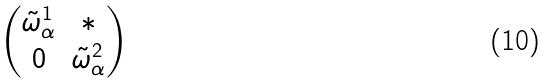Convert formula to latex. <formula><loc_0><loc_0><loc_500><loc_500>\begin{pmatrix} \tilde { \omega } _ { \alpha } ^ { 1 } & * \\ 0 & \tilde { \omega } _ { \alpha } ^ { 2 } \end{pmatrix}</formula> 